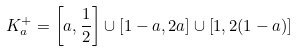<formula> <loc_0><loc_0><loc_500><loc_500>K _ { a } ^ { + } = \left [ a , \frac { 1 } { 2 } \right ] \cup \left [ 1 - a , 2 a \right ] \cup \left [ 1 , 2 ( 1 - a ) \right ]</formula> 